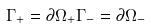Convert formula to latex. <formula><loc_0><loc_0><loc_500><loc_500>\Gamma _ { + } = \partial \Omega _ { + } { \Gamma } _ { - } = \partial \Omega _ { - }</formula> 